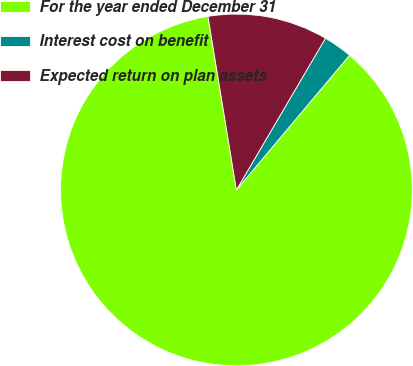Convert chart to OTSL. <chart><loc_0><loc_0><loc_500><loc_500><pie_chart><fcel>For the year ended December 31<fcel>Interest cost on benefit<fcel>Expected return on plan assets<nl><fcel>86.29%<fcel>2.67%<fcel>11.03%<nl></chart> 